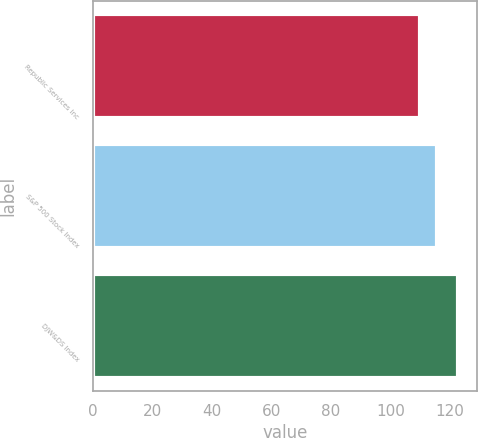Convert chart to OTSL. <chart><loc_0><loc_0><loc_500><loc_500><bar_chart><fcel>Republic Services Inc<fcel>S&P 500 Stock Index<fcel>DJW&DS Index<nl><fcel>109.91<fcel>115.8<fcel>122.88<nl></chart> 